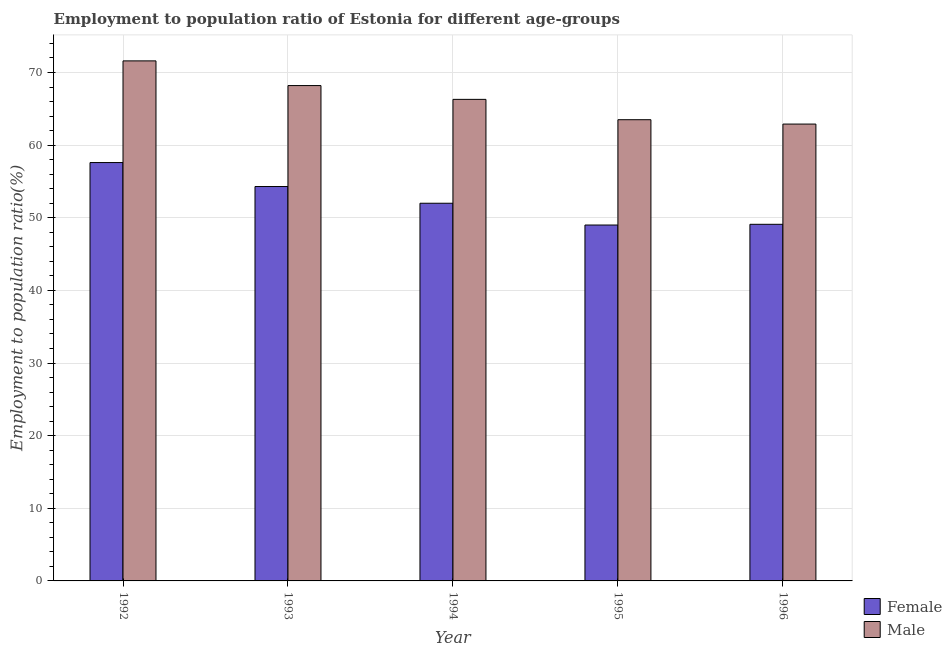How many different coloured bars are there?
Your answer should be very brief. 2. How many groups of bars are there?
Keep it short and to the point. 5. Are the number of bars on each tick of the X-axis equal?
Make the answer very short. Yes. How many bars are there on the 2nd tick from the left?
Make the answer very short. 2. What is the label of the 1st group of bars from the left?
Provide a succinct answer. 1992. What is the employment to population ratio(male) in 1992?
Your answer should be compact. 71.6. Across all years, what is the maximum employment to population ratio(male)?
Offer a terse response. 71.6. In which year was the employment to population ratio(male) minimum?
Make the answer very short. 1996. What is the total employment to population ratio(female) in the graph?
Your answer should be compact. 262. What is the difference between the employment to population ratio(male) in 1992 and that in 1993?
Ensure brevity in your answer.  3.4. What is the difference between the employment to population ratio(female) in 1995 and the employment to population ratio(male) in 1996?
Your response must be concise. -0.1. What is the average employment to population ratio(male) per year?
Ensure brevity in your answer.  66.5. In how many years, is the employment to population ratio(male) greater than 64 %?
Give a very brief answer. 3. What is the ratio of the employment to population ratio(male) in 1992 to that in 1994?
Keep it short and to the point. 1.08. Is the difference between the employment to population ratio(female) in 1992 and 1995 greater than the difference between the employment to population ratio(male) in 1992 and 1995?
Offer a terse response. No. What is the difference between the highest and the second highest employment to population ratio(male)?
Ensure brevity in your answer.  3.4. What is the difference between the highest and the lowest employment to population ratio(male)?
Your answer should be compact. 8.7. In how many years, is the employment to population ratio(male) greater than the average employment to population ratio(male) taken over all years?
Your answer should be very brief. 2. Is the sum of the employment to population ratio(male) in 1994 and 1995 greater than the maximum employment to population ratio(female) across all years?
Offer a very short reply. Yes. What does the 1st bar from the left in 1996 represents?
Provide a succinct answer. Female. What does the 1st bar from the right in 1994 represents?
Provide a short and direct response. Male. How many bars are there?
Ensure brevity in your answer.  10. How many years are there in the graph?
Offer a terse response. 5. Are the values on the major ticks of Y-axis written in scientific E-notation?
Provide a succinct answer. No. How many legend labels are there?
Your answer should be compact. 2. How are the legend labels stacked?
Offer a terse response. Vertical. What is the title of the graph?
Your answer should be very brief. Employment to population ratio of Estonia for different age-groups. What is the Employment to population ratio(%) in Female in 1992?
Provide a short and direct response. 57.6. What is the Employment to population ratio(%) in Male in 1992?
Provide a succinct answer. 71.6. What is the Employment to population ratio(%) of Female in 1993?
Offer a terse response. 54.3. What is the Employment to population ratio(%) in Male in 1993?
Give a very brief answer. 68.2. What is the Employment to population ratio(%) of Male in 1994?
Ensure brevity in your answer.  66.3. What is the Employment to population ratio(%) in Female in 1995?
Make the answer very short. 49. What is the Employment to population ratio(%) of Male in 1995?
Keep it short and to the point. 63.5. What is the Employment to population ratio(%) in Female in 1996?
Make the answer very short. 49.1. What is the Employment to population ratio(%) of Male in 1996?
Keep it short and to the point. 62.9. Across all years, what is the maximum Employment to population ratio(%) of Female?
Provide a short and direct response. 57.6. Across all years, what is the maximum Employment to population ratio(%) of Male?
Your response must be concise. 71.6. Across all years, what is the minimum Employment to population ratio(%) in Female?
Your answer should be compact. 49. Across all years, what is the minimum Employment to population ratio(%) in Male?
Ensure brevity in your answer.  62.9. What is the total Employment to population ratio(%) in Female in the graph?
Give a very brief answer. 262. What is the total Employment to population ratio(%) in Male in the graph?
Keep it short and to the point. 332.5. What is the difference between the Employment to population ratio(%) of Female in 1992 and that in 1993?
Give a very brief answer. 3.3. What is the difference between the Employment to population ratio(%) in Male in 1992 and that in 1994?
Your answer should be very brief. 5.3. What is the difference between the Employment to population ratio(%) in Female in 1992 and that in 1996?
Make the answer very short. 8.5. What is the difference between the Employment to population ratio(%) of Female in 1993 and that in 1996?
Offer a terse response. 5.2. What is the difference between the Employment to population ratio(%) of Female in 1994 and that in 1995?
Keep it short and to the point. 3. What is the difference between the Employment to population ratio(%) in Male in 1995 and that in 1996?
Give a very brief answer. 0.6. What is the difference between the Employment to population ratio(%) in Female in 1992 and the Employment to population ratio(%) in Male in 1994?
Offer a terse response. -8.7. What is the difference between the Employment to population ratio(%) in Female in 1992 and the Employment to population ratio(%) in Male in 1995?
Your answer should be very brief. -5.9. What is the difference between the Employment to population ratio(%) in Female in 1992 and the Employment to population ratio(%) in Male in 1996?
Provide a succinct answer. -5.3. What is the difference between the Employment to population ratio(%) of Female in 1993 and the Employment to population ratio(%) of Male in 1995?
Provide a succinct answer. -9.2. What is the difference between the Employment to population ratio(%) in Female in 1994 and the Employment to population ratio(%) in Male in 1995?
Provide a short and direct response. -11.5. What is the difference between the Employment to population ratio(%) of Female in 1994 and the Employment to population ratio(%) of Male in 1996?
Offer a terse response. -10.9. What is the average Employment to population ratio(%) in Female per year?
Provide a short and direct response. 52.4. What is the average Employment to population ratio(%) in Male per year?
Provide a succinct answer. 66.5. In the year 1993, what is the difference between the Employment to population ratio(%) in Female and Employment to population ratio(%) in Male?
Ensure brevity in your answer.  -13.9. In the year 1994, what is the difference between the Employment to population ratio(%) in Female and Employment to population ratio(%) in Male?
Provide a short and direct response. -14.3. In the year 1996, what is the difference between the Employment to population ratio(%) of Female and Employment to population ratio(%) of Male?
Offer a very short reply. -13.8. What is the ratio of the Employment to population ratio(%) of Female in 1992 to that in 1993?
Offer a very short reply. 1.06. What is the ratio of the Employment to population ratio(%) of Male in 1992 to that in 1993?
Ensure brevity in your answer.  1.05. What is the ratio of the Employment to population ratio(%) in Female in 1992 to that in 1994?
Make the answer very short. 1.11. What is the ratio of the Employment to population ratio(%) of Male in 1992 to that in 1994?
Offer a very short reply. 1.08. What is the ratio of the Employment to population ratio(%) in Female in 1992 to that in 1995?
Offer a very short reply. 1.18. What is the ratio of the Employment to population ratio(%) of Male in 1992 to that in 1995?
Provide a succinct answer. 1.13. What is the ratio of the Employment to population ratio(%) in Female in 1992 to that in 1996?
Your answer should be very brief. 1.17. What is the ratio of the Employment to population ratio(%) of Male in 1992 to that in 1996?
Keep it short and to the point. 1.14. What is the ratio of the Employment to population ratio(%) of Female in 1993 to that in 1994?
Provide a short and direct response. 1.04. What is the ratio of the Employment to population ratio(%) in Male in 1993 to that in 1994?
Provide a succinct answer. 1.03. What is the ratio of the Employment to population ratio(%) in Female in 1993 to that in 1995?
Offer a very short reply. 1.11. What is the ratio of the Employment to population ratio(%) in Male in 1993 to that in 1995?
Ensure brevity in your answer.  1.07. What is the ratio of the Employment to population ratio(%) in Female in 1993 to that in 1996?
Offer a terse response. 1.11. What is the ratio of the Employment to population ratio(%) of Male in 1993 to that in 1996?
Provide a succinct answer. 1.08. What is the ratio of the Employment to population ratio(%) in Female in 1994 to that in 1995?
Offer a terse response. 1.06. What is the ratio of the Employment to population ratio(%) of Male in 1994 to that in 1995?
Provide a succinct answer. 1.04. What is the ratio of the Employment to population ratio(%) in Female in 1994 to that in 1996?
Ensure brevity in your answer.  1.06. What is the ratio of the Employment to population ratio(%) in Male in 1994 to that in 1996?
Your response must be concise. 1.05. What is the ratio of the Employment to population ratio(%) in Female in 1995 to that in 1996?
Offer a very short reply. 1. What is the ratio of the Employment to population ratio(%) in Male in 1995 to that in 1996?
Ensure brevity in your answer.  1.01. What is the difference between the highest and the second highest Employment to population ratio(%) in Female?
Provide a succinct answer. 3.3. 